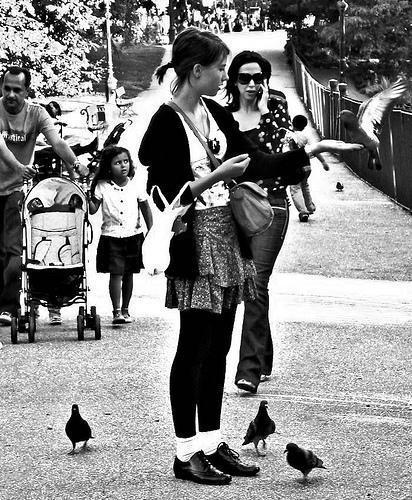How many birds are surrounding the women in the skirts feet?
Give a very brief answer. 3. How many people are feeding birds?
Give a very brief answer. 1. 